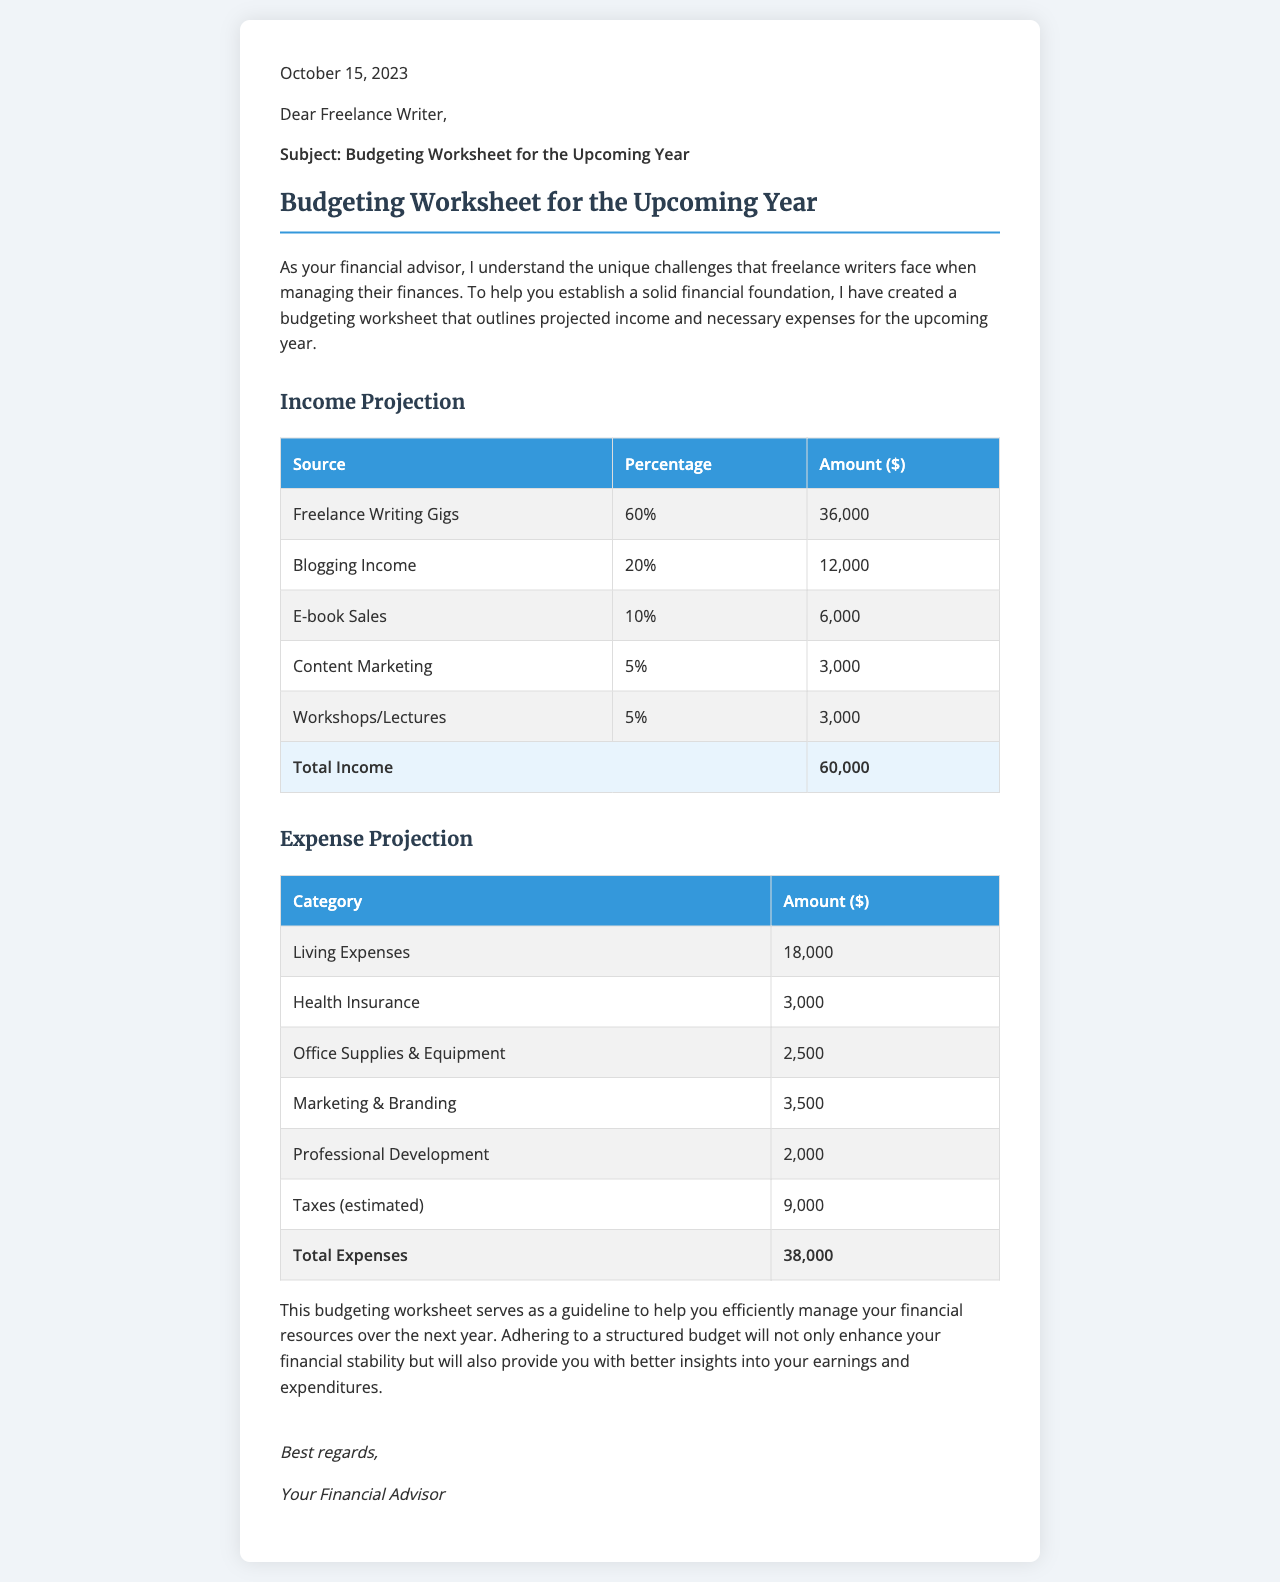What is the total projected income? The total projected income is listed at the end of the income projection table, which combines all the income sources.
Answer: 60,000 What percentage of the total income comes from freelance writing gigs? The percentage for freelance writing gigs is specified in the income projection table.
Answer: 60% How much is allocated for health insurance? The amount for health insurance is provided in the expense projection table.
Answer: 3,000 What is the total amount set for living expenses? The total living expenses are indicated in the expense projection table.
Answer: 18,000 What category has the highest expense? The category with the highest expense can be deduced from the expenses listed in the expense projection table.
Answer: Taxes (estimated) What percentage of total income comes from blogging income? The percentage for blogging income is specified in the income projection table.
Answer: 20% What is the projected amount for workshops/lectures? The projected amount for workshops/lectures is found in the income projection table.
Answer: 3,000 What is the date of the letter? The date of the letter is included at the top of the document.
Answer: October 15, 2023 What is the primary purpose of the budgeting worksheet? The purpose of the budgeting worksheet is mentioned in the introduction of the letter.
Answer: Financial management 